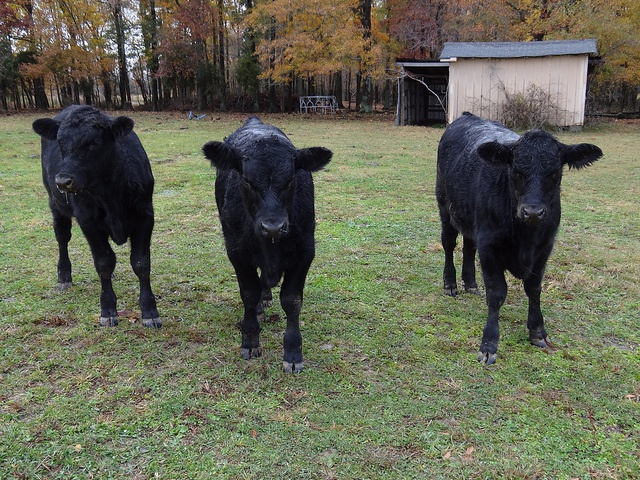Describe the objects in this image and their specific colors. I can see cow in maroon, black, gray, and darkgray tones, cow in maroon, black, and gray tones, and cow in maroon, black, and gray tones in this image. 